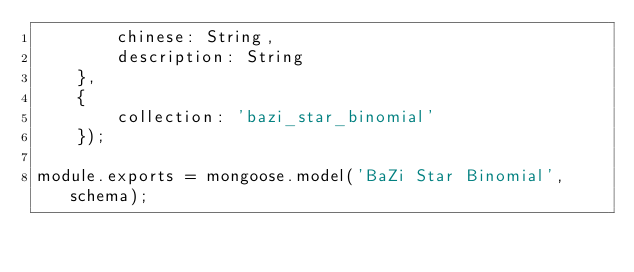Convert code to text. <code><loc_0><loc_0><loc_500><loc_500><_JavaScript_>        chinese: String,
        description: String
    },
    {
        collection: 'bazi_star_binomial'
    });

module.exports = mongoose.model('BaZi Star Binomial', schema);</code> 